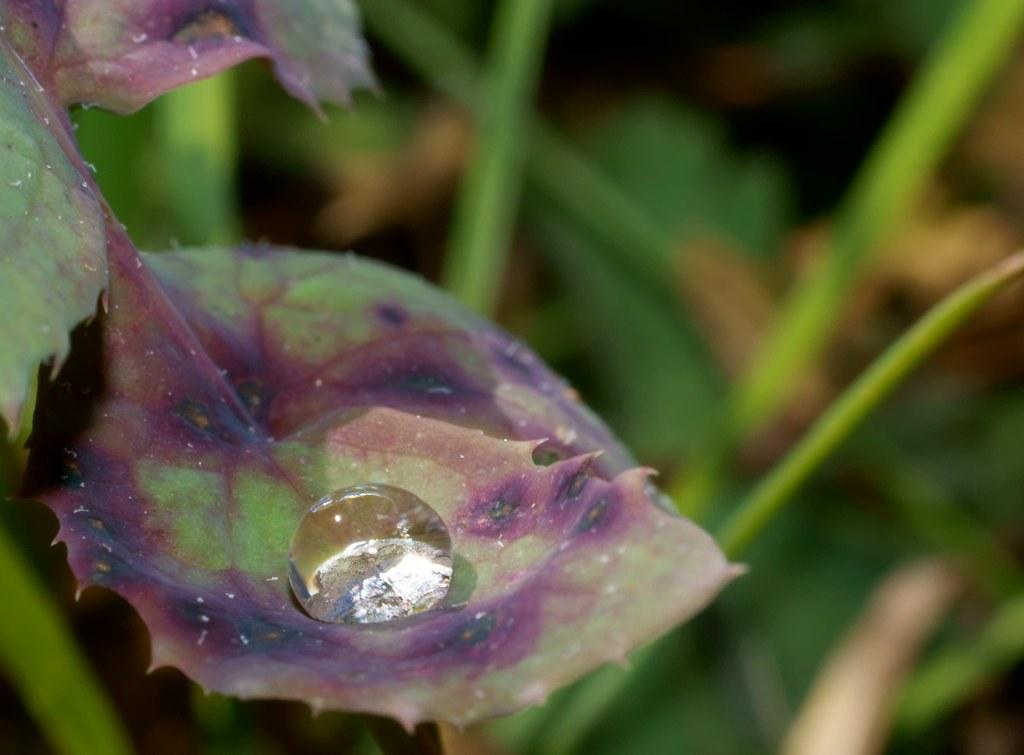What is the main subject in the center of the image? There are leaves in the center of the image. Can you describe any specific details about the leaves? Yes, there is a water drop on one of the leaves. What can be seen in the background of the image? There are plants visible in the background of the image. What type of belief is represented by the cars in the image? There are no cars present in the image, so it is not possible to determine any beliefs represented by them. 